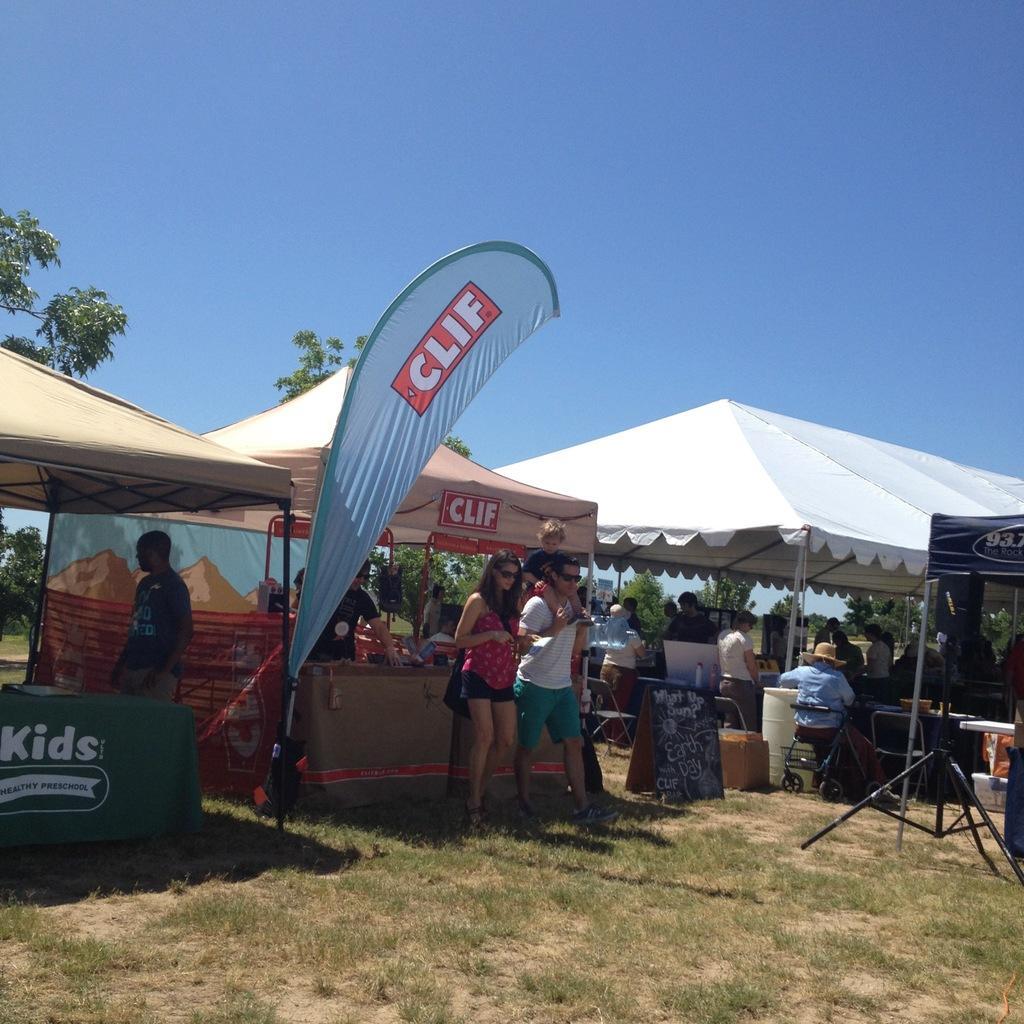Can you describe this image briefly? At the bottom I can see grass and a camera stand. In the middle I can see a crowd, tents and trees. On the top I can see the sky. This image is taken during a day. 